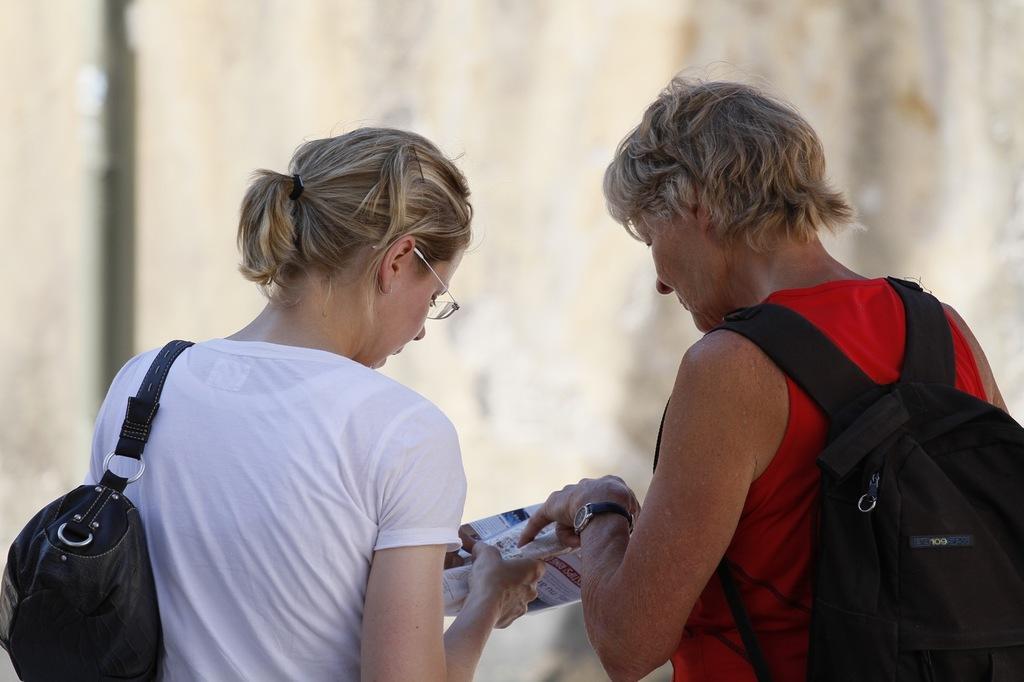Please provide a concise description of this image. This picture shows two men standing and a woman wore a backpack on her back and a woman holds a paper in her hand and she wore a handbag 